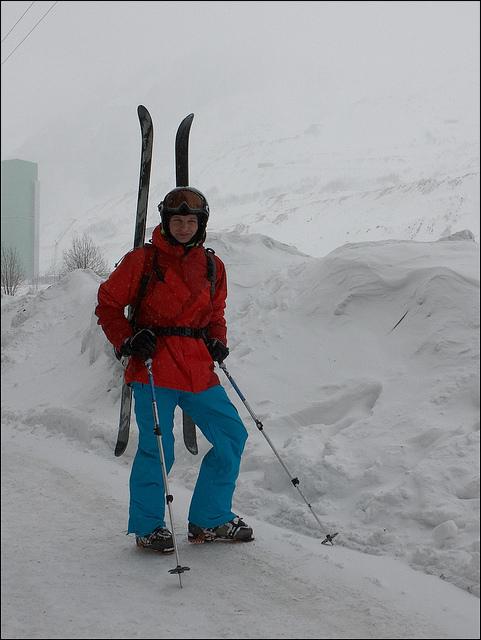Where does this picture take place?
Be succinct. Ski resort. Where are the poles?
Give a very brief answer. In hands. Is it sunny?
Be succinct. No. What is on the man's head?
Be succinct. Helmet. Is this an old photo?
Write a very short answer. No. What are the people doing?
Give a very brief answer. Skiing. What is the person carrying on their back?
Write a very short answer. Skis. Is this a modern photo?
Write a very short answer. Yes. What color is the person's' jacket?
Give a very brief answer. Red. Is he carrying skis on his back?
Answer briefly. Yes. Are there any trees pictured?
Write a very short answer. No. What is the man doing?
Answer briefly. Skiing. Is the skier traveling slowly?
Answer briefly. Yes. How many people?
Concise answer only. 1. What sport is the man participating in?
Quick response, please. Skiing. What color is the ground the person is walking on?
Be succinct. White. 